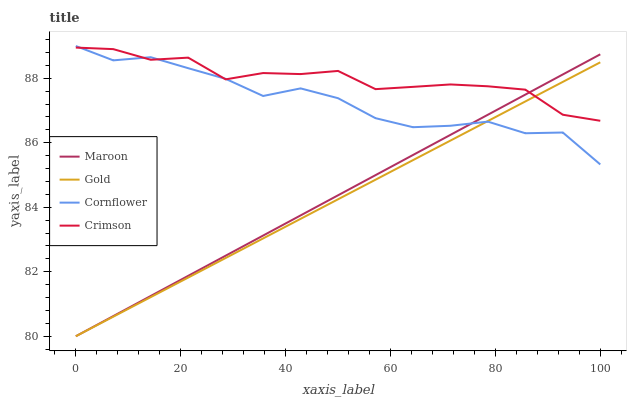Does Gold have the minimum area under the curve?
Answer yes or no. Yes. Does Crimson have the maximum area under the curve?
Answer yes or no. Yes. Does Cornflower have the minimum area under the curve?
Answer yes or no. No. Does Cornflower have the maximum area under the curve?
Answer yes or no. No. Is Gold the smoothest?
Answer yes or no. Yes. Is Cornflower the roughest?
Answer yes or no. Yes. Is Cornflower the smoothest?
Answer yes or no. No. Is Gold the roughest?
Answer yes or no. No. Does Cornflower have the lowest value?
Answer yes or no. No. Does Cornflower have the highest value?
Answer yes or no. Yes. Does Gold have the highest value?
Answer yes or no. No. Does Maroon intersect Cornflower?
Answer yes or no. Yes. Is Maroon less than Cornflower?
Answer yes or no. No. Is Maroon greater than Cornflower?
Answer yes or no. No. 